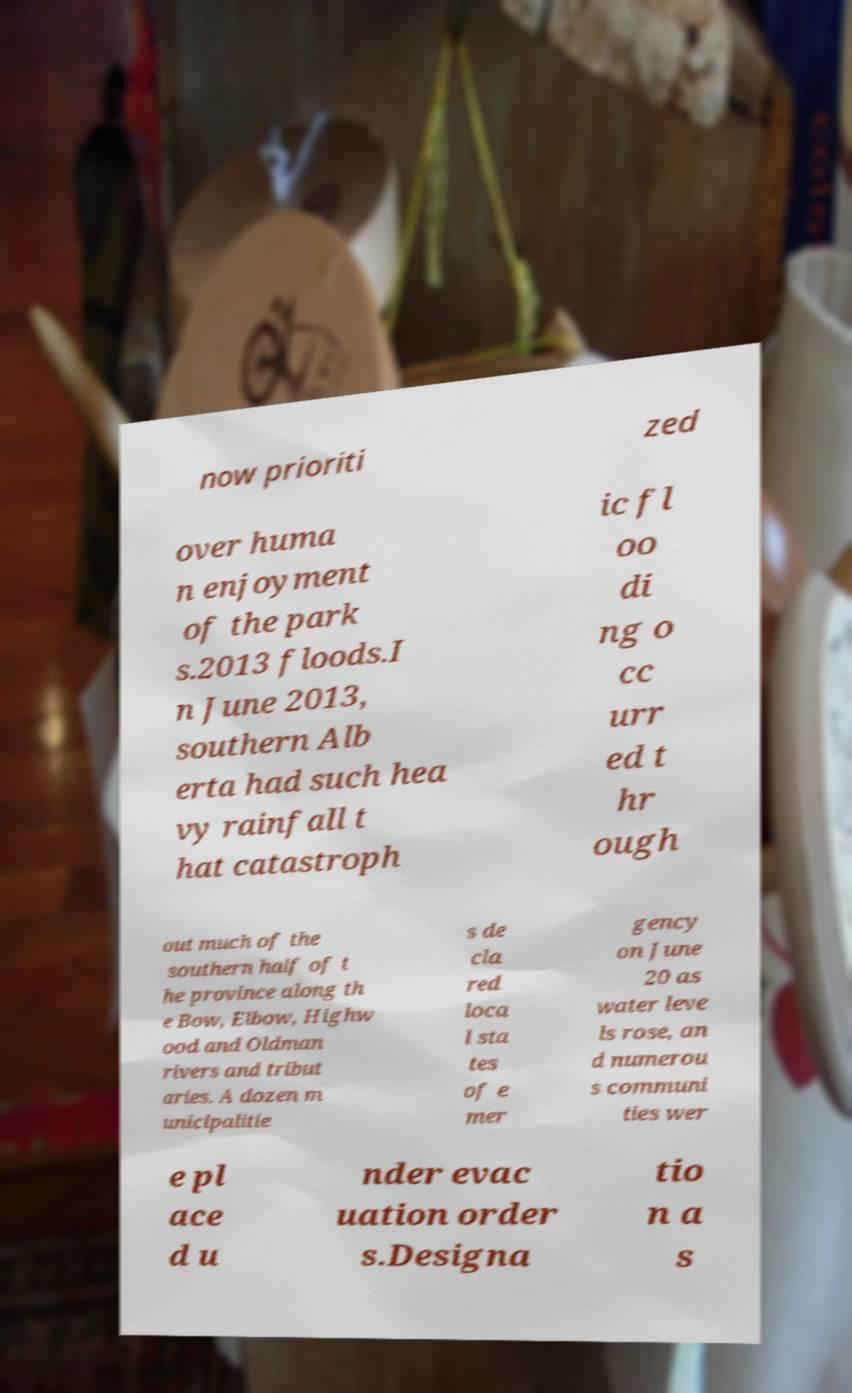There's text embedded in this image that I need extracted. Can you transcribe it verbatim? now prioriti zed over huma n enjoyment of the park s.2013 floods.I n June 2013, southern Alb erta had such hea vy rainfall t hat catastroph ic fl oo di ng o cc urr ed t hr ough out much of the southern half of t he province along th e Bow, Elbow, Highw ood and Oldman rivers and tribut aries. A dozen m unicipalitie s de cla red loca l sta tes of e mer gency on June 20 as water leve ls rose, an d numerou s communi ties wer e pl ace d u nder evac uation order s.Designa tio n a s 